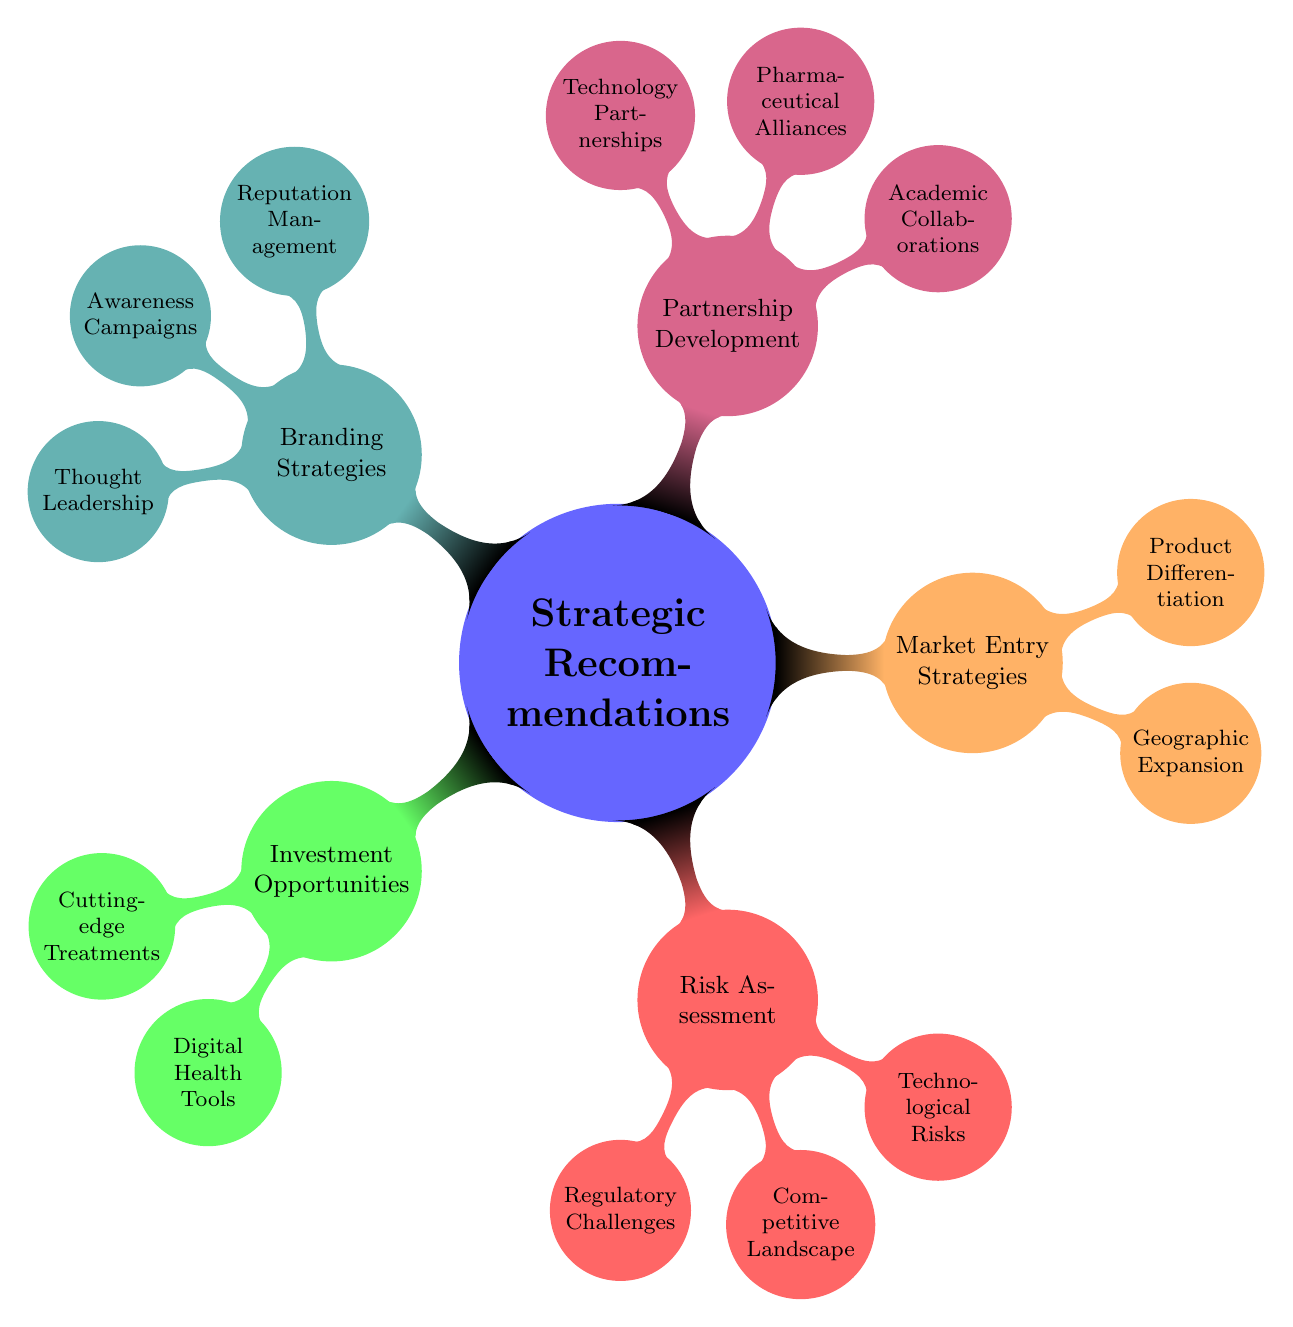What are two examples of cutting-edge treatments listed in the diagram? The node under Investment Opportunities titled "Cutting-edge Treatments" lists "CRISPR Gene Editing" and "RNA-based Therapies" as specific examples.
Answer: CRISPR Gene Editing, RNA-based Therapies How many major branches are there in the diagram? The main node "Strategic Recommendations" has five sub-nodes, indicating five major branches in total: Investment Opportunities, Risk Assessment, Market Entry Strategies, Partnership Development, and Branding Strategies.
Answer: 5 What type of risks fall under Regulatory Challenges? Within the category of Risk Assessment, the Regulatory Challenges sub-node specifies issues related to "FDA Approval" and "EMA Compliance."
Answer: FDA Approval, EMA Compliance What is one major potential partnership type mentioned for partnership development? The node labeled "Partnership Development" indicates three categories, one of which is "Academic Collaborations." Thus, one major potential partnership type is specifically highlighted as academic.
Answer: Academic Collaborations Which two types of strategies are listed under Branding Strategies? The Branding Strategies node includes three categories, two of which are "Reputation Management" and "Awareness Campaigns." Therefore, these are the two types of strategies listed.
Answer: Reputation Management, Awareness Campaigns What is required for a company aiming for Geographic Expansion according to the Market Entry Strategies? Under Market Entry Strategies, the Geographic Expansion node lists "Emerging Asian Markets" and "European Union Opportunities," thus identifying these regions as necessary targets for expansion.
Answer: Emerging Asian Markets, European Union Opportunities How many specific examples are provided for Digital Health Tools? Under the Investment Opportunities node, there are two specific examples listed under Digital Health Tools: "Telemedicine Solutions" and "Remote Monitoring Devices."
Answer: 2 What is a critical aspect of the Technological Risks mentioned? Within the Risk Assessment section, the Technological Risks node includes "Data Security" and "Emerging Tech Reliability," highlighting their importance as critical aspects of technology risks.
Answer: Data Security, Emerging Tech Reliability 